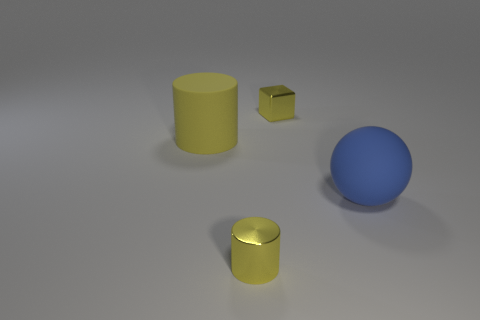Is the material of the blue ball the same as the big thing that is on the left side of the tiny cube?
Offer a very short reply. Yes. How big is the metallic object that is in front of the matte object that is on the right side of the tiny yellow cube?
Provide a short and direct response. Small. Is there any other thing that has the same color as the small cube?
Give a very brief answer. Yes. Is the material of the cylinder that is in front of the ball the same as the large object to the right of the yellow rubber thing?
Provide a succinct answer. No. There is a yellow object that is both to the left of the yellow cube and behind the large blue sphere; what material is it?
Offer a terse response. Rubber. There is a large yellow matte object; is its shape the same as the yellow object that is behind the big cylinder?
Your answer should be compact. No. What material is the tiny thing that is behind the cylinder behind the big object that is on the right side of the block?
Provide a short and direct response. Metal. What number of other objects are there of the same size as the block?
Ensure brevity in your answer.  1. Does the matte cylinder have the same color as the small cube?
Make the answer very short. Yes. What number of cylinders are in front of the cylinder behind the matte thing that is right of the shiny cube?
Keep it short and to the point. 1. 